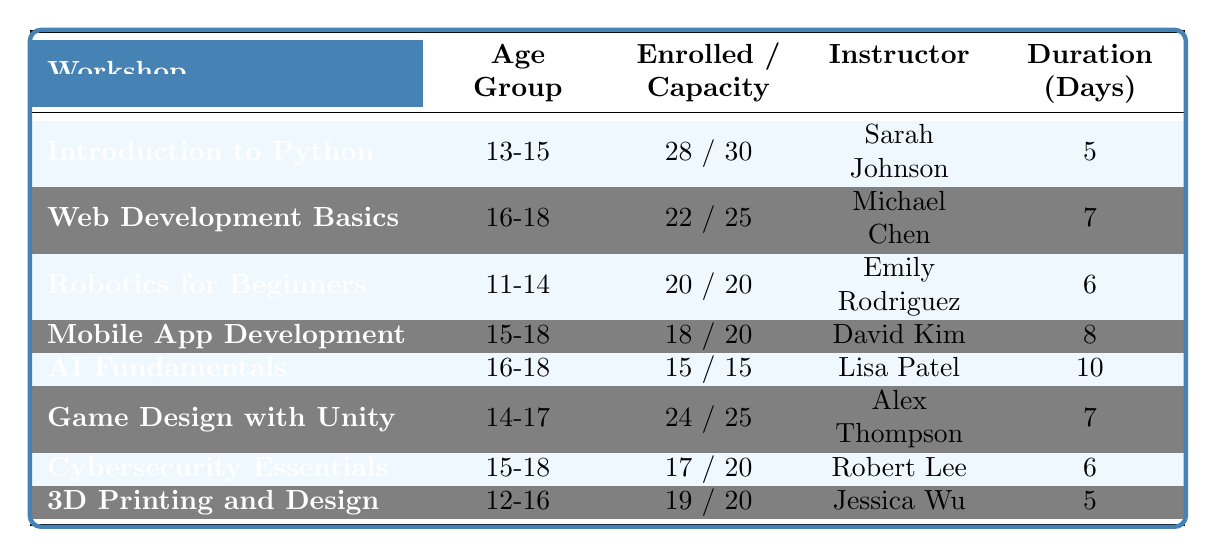What is the enrollment count for the "Game Design with Unity" workshop? The table lists "Game Design with Unity" under the workshop name, and the corresponding enrollment count is specified as 24.
Answer: 24 Which workshop has the maximum enrollment capacity? By examining the table's capacity values, we see that both "Robotics for Beginners" and "Artificial Intelligence Fundamentals" have a maximum capacity of 20, but "Robotics for Beginners" has reached its full capacity with an enrollment of 20.
Answer: Robotics for Beginners How many students are enrolled in workshops for the age group "15-18"? The workshops for the age group "15-18" are "Mobile App Development," "Artificial Intelligence Fundamentals," and "Cybersecurity Essentials," which have 18, 15, and 17 enrollments respectively. Adding these gives 18 + 15 + 17 = 50.
Answer: 50 What is the total difference in enrollment between the workshops with the highest and lowest enrollment counts? The highest enrollment count is for "Introduction to Python" with 28, and the lowest is for "Artificial Intelligence Fundamentals" with 15. The difference is calculated as 28 - 15 = 13.
Answer: 13 Are there any workshops that are fully enrolled? Checking the table, the workshop "Robotics for Beginners" is listed with an enrollment of 20 out of a maximum of 20, indicating it is fully enrolled.
Answer: Yes Which instructor teaches the workshop with the longest duration? "Artificial Intelligence Fundamentals" is listed as having a duration of 10 days, which is the longest in the table. The instructor is Lisa Patel.
Answer: Lisa Patel How many workshops have an enrollment count that is at least 80% of their maximum capacity? The workshops are: "Introduction to Python" (28/30 = 93%), "Web Development Basics" (22/25 = 88%), "Game Design with Unity" (24/25 = 96%), and "Robotics for Beginners" (20/20 = 100%). Counting these gives us 4 workshops.
Answer: 4 Is there any workshop with an enrollment count equal to its maximum capacity? Yes, checking the table we see that "Robotics for Beginners" has an enrollment count of 20 with a maximum capacity of 20, so it meets this criterion.
Answer: Yes What is the average enrollment across all the workshops? The total enrollment adds up to 28 + 22 + 20 + 18 + 15 + 24 + 17 + 19 = 183. There are 8 workshops, so the average enrollment is 183 / 8 = 22.875.
Answer: 22.875 Which age group has the highest enrollment in their workshop? Looking at the workshops, the group "13-15" in "Introduction to Python" has 28 enrollments, which is higher than any other age group’s enrollment.
Answer: 13-15 